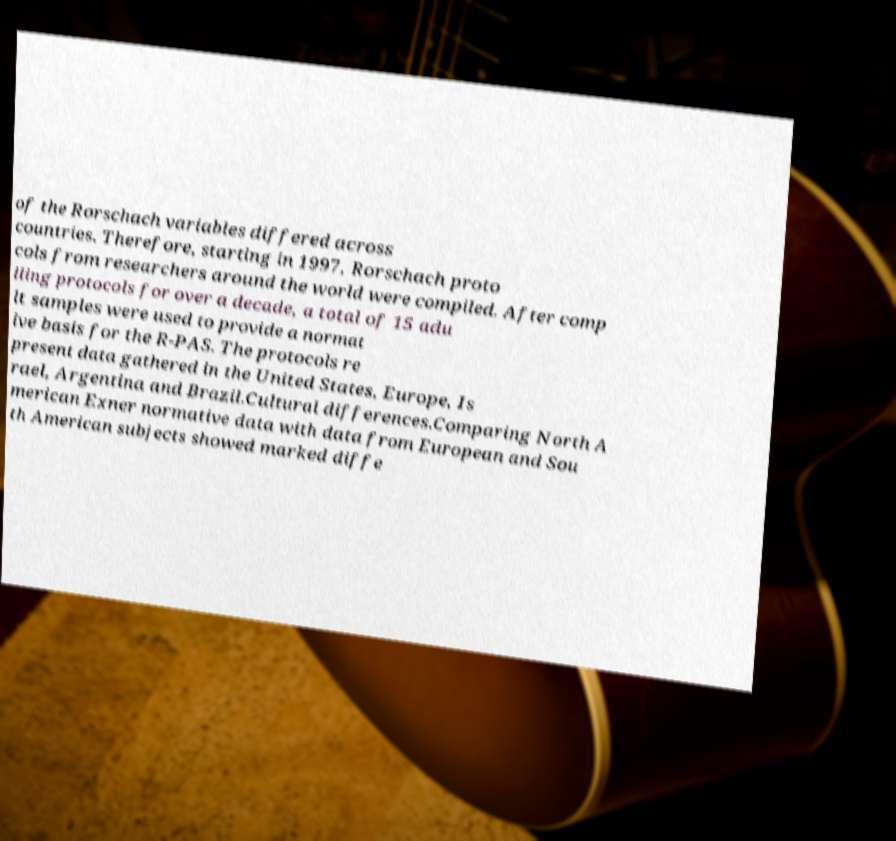Can you read and provide the text displayed in the image?This photo seems to have some interesting text. Can you extract and type it out for me? of the Rorschach variables differed across countries. Therefore, starting in 1997, Rorschach proto cols from researchers around the world were compiled. After comp iling protocols for over a decade, a total of 15 adu lt samples were used to provide a normat ive basis for the R-PAS. The protocols re present data gathered in the United States, Europe, Is rael, Argentina and Brazil.Cultural differences.Comparing North A merican Exner normative data with data from European and Sou th American subjects showed marked diffe 